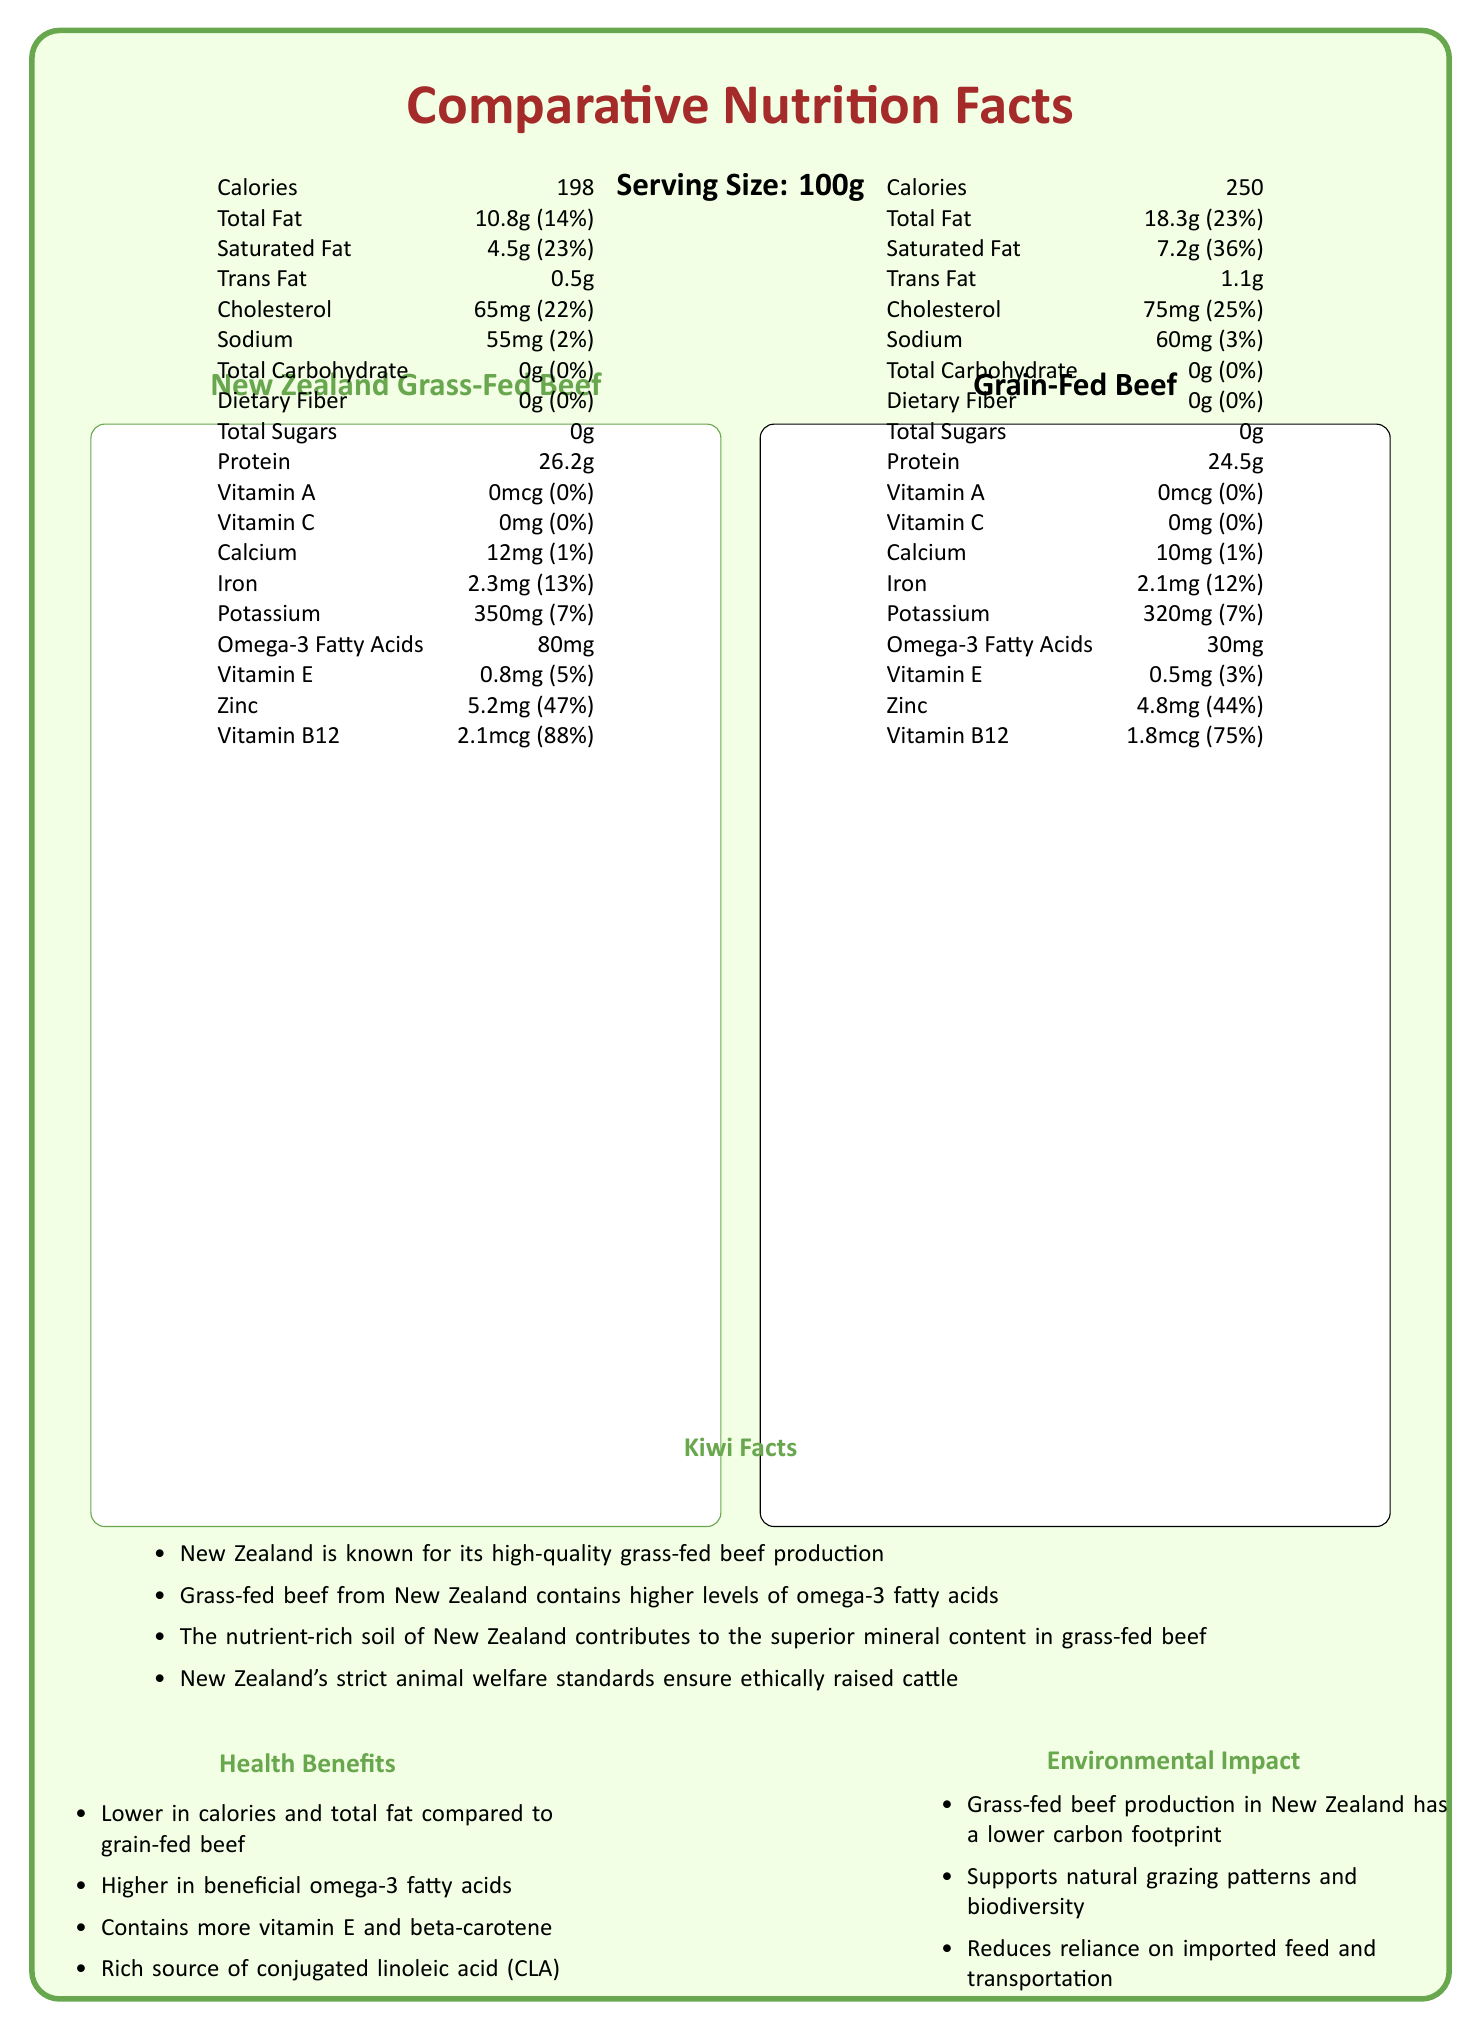what is the serving size for both types of beef? The serving size is listed as "Serving Size: 100g" for both New Zealand Grass-Fed Beef and Grain-Fed Beef.
Answer: 100g which type of beef contains more calories? The calories for New Zealand Grass-Fed Beef are 198, while Grain-Fed Beef contains 250 calories. Therefore, Grain-Fed Beef contains more calories.
Answer: Grain-Fed Beef how much iron does New Zealand Grass-Fed Beef contain? Refer to the iron content under New Zealand Grass-Fed Beef, which is listed as "Iron: 2.3mg".
Answer: 2.3mg which type of beef has a higher Vitamin B12 content? A. New Zealand Grass-Fed Beef B. Grain-Fed Beef New Zealand Grass-Fed Beef contains 2.1mcg of Vitamin B12, while Grain-Fed Beef has only 1.8mcg.
Answer: A what is the total fat content of Grain-Fed Beef? The total fat content for Grain-Fed Beef is listed as "Total Fat: 18.3g".
Answer: 18.3g does New Zealand Grass-Fed Beef contain any dietary fiber? The dietary fiber content for New Zealand Grass-Fed Beef is 0g, indicating it contains no dietary fiber.
Answer: No which beef has higher omega-3 fatty acids? New Zealand Grass-Fed Beef has 80mg of omega-3 fatty acids, while Grain-Fed Beef has only 30mg.
Answer: New Zealand Grass-Fed Beef what is the daily value percentage of saturated fat in Grain-Fed Beef? The daily value percentage of saturated fat in Grain-Fed Beef is listed as 36%.
Answer: 36% which type of beef has a higher zinc content? A. New Zealand Grass-Fed Beef B. Grain-Fed Beef New Zealand Grass-Fed Beef has 5.2mg of zinc compared to Grain-Fed Beef, which has 4.8mg.
Answer: A true or false: Grain-Fed Beef has a higher vitamin C content than New Zealand Grass-Fed Beef. Both types of beef contain 0mg of Vitamin C.
Answer: False what is the main idea of the document? The document provides a comparative analysis of the nutritional content between New Zealand Grass-Fed Beef and Grain-Fed Beef, along with additional information on the benefits of grass-fed beef and its environmental impact.
Answer: Comparing Nutritional Information of Beef how much potassium does New Zealand Grass-Fed Beef contain? The potassium content of New Zealand Grass-Fed Beef is listed as 350mg.
Answer: 350mg which beef has lower cholesterol content? A. New Zealand Grass-Fed Beef B. Grain-Fed Beef New Zealand Grass-Fed Beef contains 65mg of cholesterol, whereas Grain-Fed Beef contains 75mg. Hence, New Zealand Grass-Fed Beef has lower cholesterol content.
Answer: A give three health benefits of New Zealand Grass-Fed Beef. The health benefits specified for New Zealand Grass-Fed Beef include it being lower in calories, higher in beneficial omega-3 fatty acids, and containing more vitamin E and beta-carotene.
Answer: Lower in calories, higher in omega-3 fatty acids, contains more vitamin E and beta-carotene what is the daily value percentage of protein in Grain-Fed Beef? The document provides the protein amount in grams but does not specify its daily value percentage.
Answer: Cannot be determined explain the environmental benefits of grass-fed beef production in New Zealand. Grass-fed beef production in New Zealand has a lower carbon footprint, supports natural grazing patterns and biodiversity, and reduces reliance on imported feed and transportation, as stated in the document.
Answer: Lower carbon footprint, supports biodiversity, reduces reliance on imports how does the nutritional content of New Zealand Grass-Fed Beef benefit those seeking Omega-3? New Zealand Grass-Fed Beef has 80mg of omega-3 fatty acids, which is higher than the 30mg found in Grain-Fed Beef, beneficial for individuals seeking to increase their omega-3 intake.
Answer: Higher omega-3 content which product has a higher potassium content? A. New Zealand Grass-Fed Beef B. Grain-Fed Beef New Zealand Grass-Fed Beef has 350mg of potassium, while Grain-Fed Beef has 320mg.
Answer: A how does the nutrient-rich soil of New Zealand impact grass-fed beef? The nutrient-rich soil contributes to the superior mineral content in New Zealand Grass-Fed Beef.
Answer: Superior mineral content name one ethical aspect of New Zealand beef production. New Zealand's strict animal welfare standards ensure ethically raised cattle, highlighting an ethical aspect of their beef production.
Answer: Strict animal welfare standards 